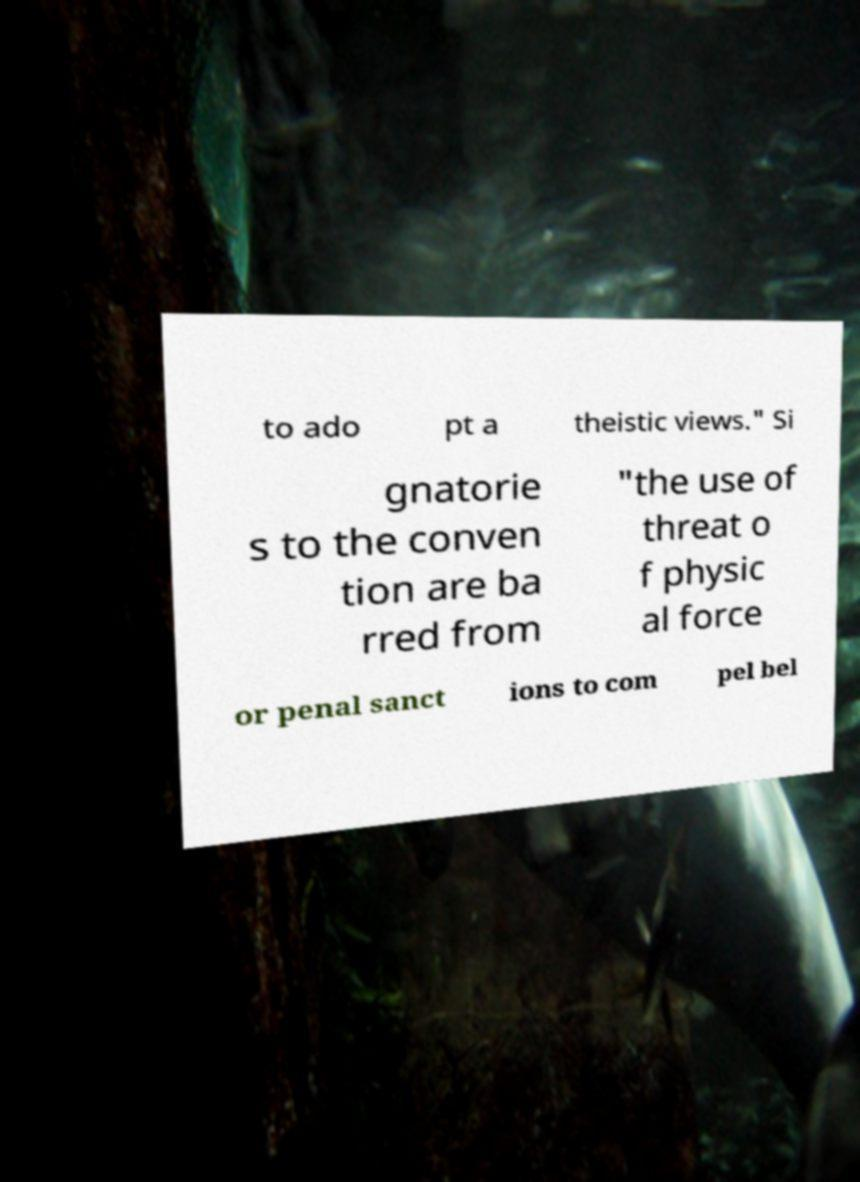Please identify and transcribe the text found in this image. to ado pt a theistic views." Si gnatorie s to the conven tion are ba rred from "the use of threat o f physic al force or penal sanct ions to com pel bel 